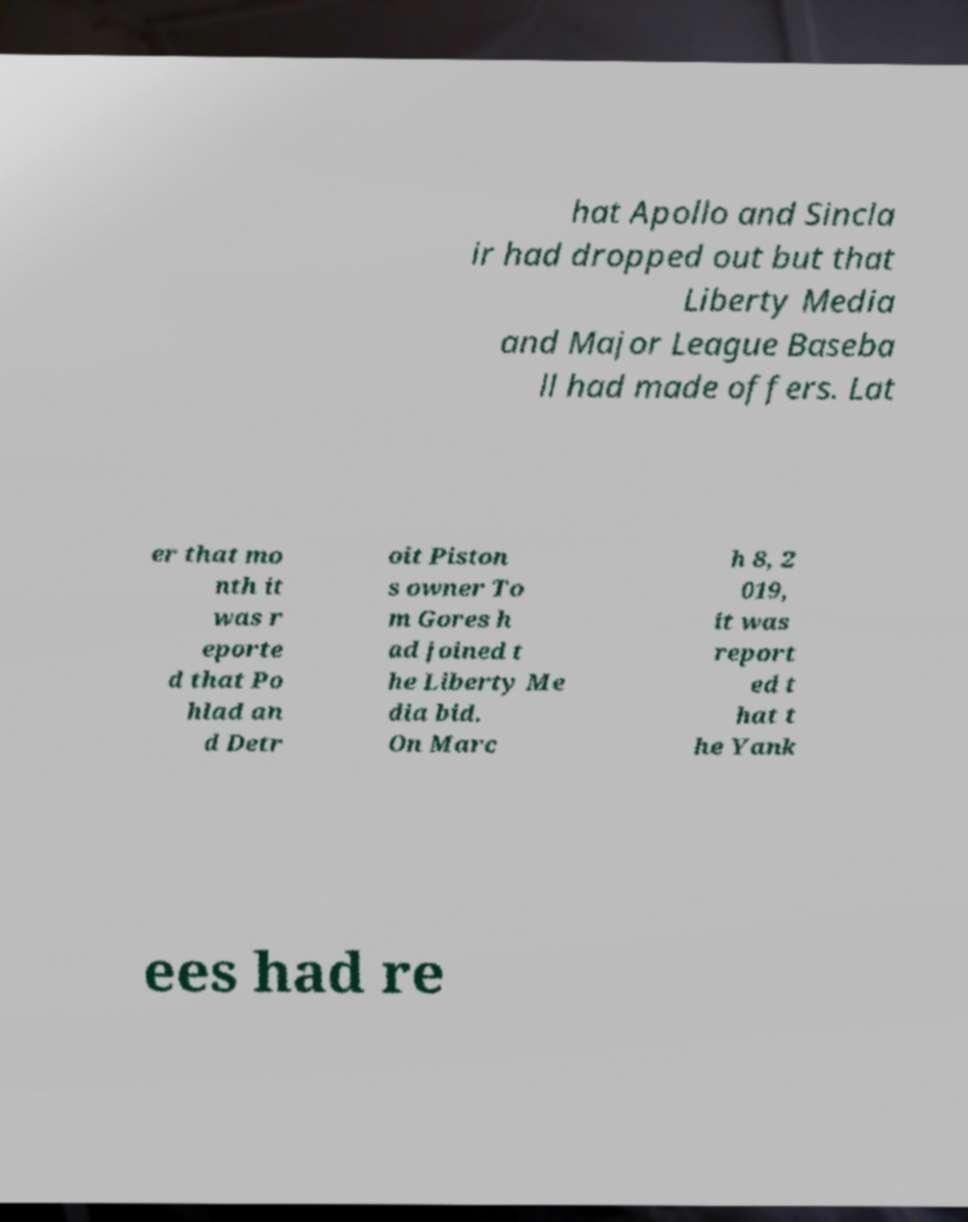What messages or text are displayed in this image? I need them in a readable, typed format. hat Apollo and Sincla ir had dropped out but that Liberty Media and Major League Baseba ll had made offers. Lat er that mo nth it was r eporte d that Po hlad an d Detr oit Piston s owner To m Gores h ad joined t he Liberty Me dia bid. On Marc h 8, 2 019, it was report ed t hat t he Yank ees had re 